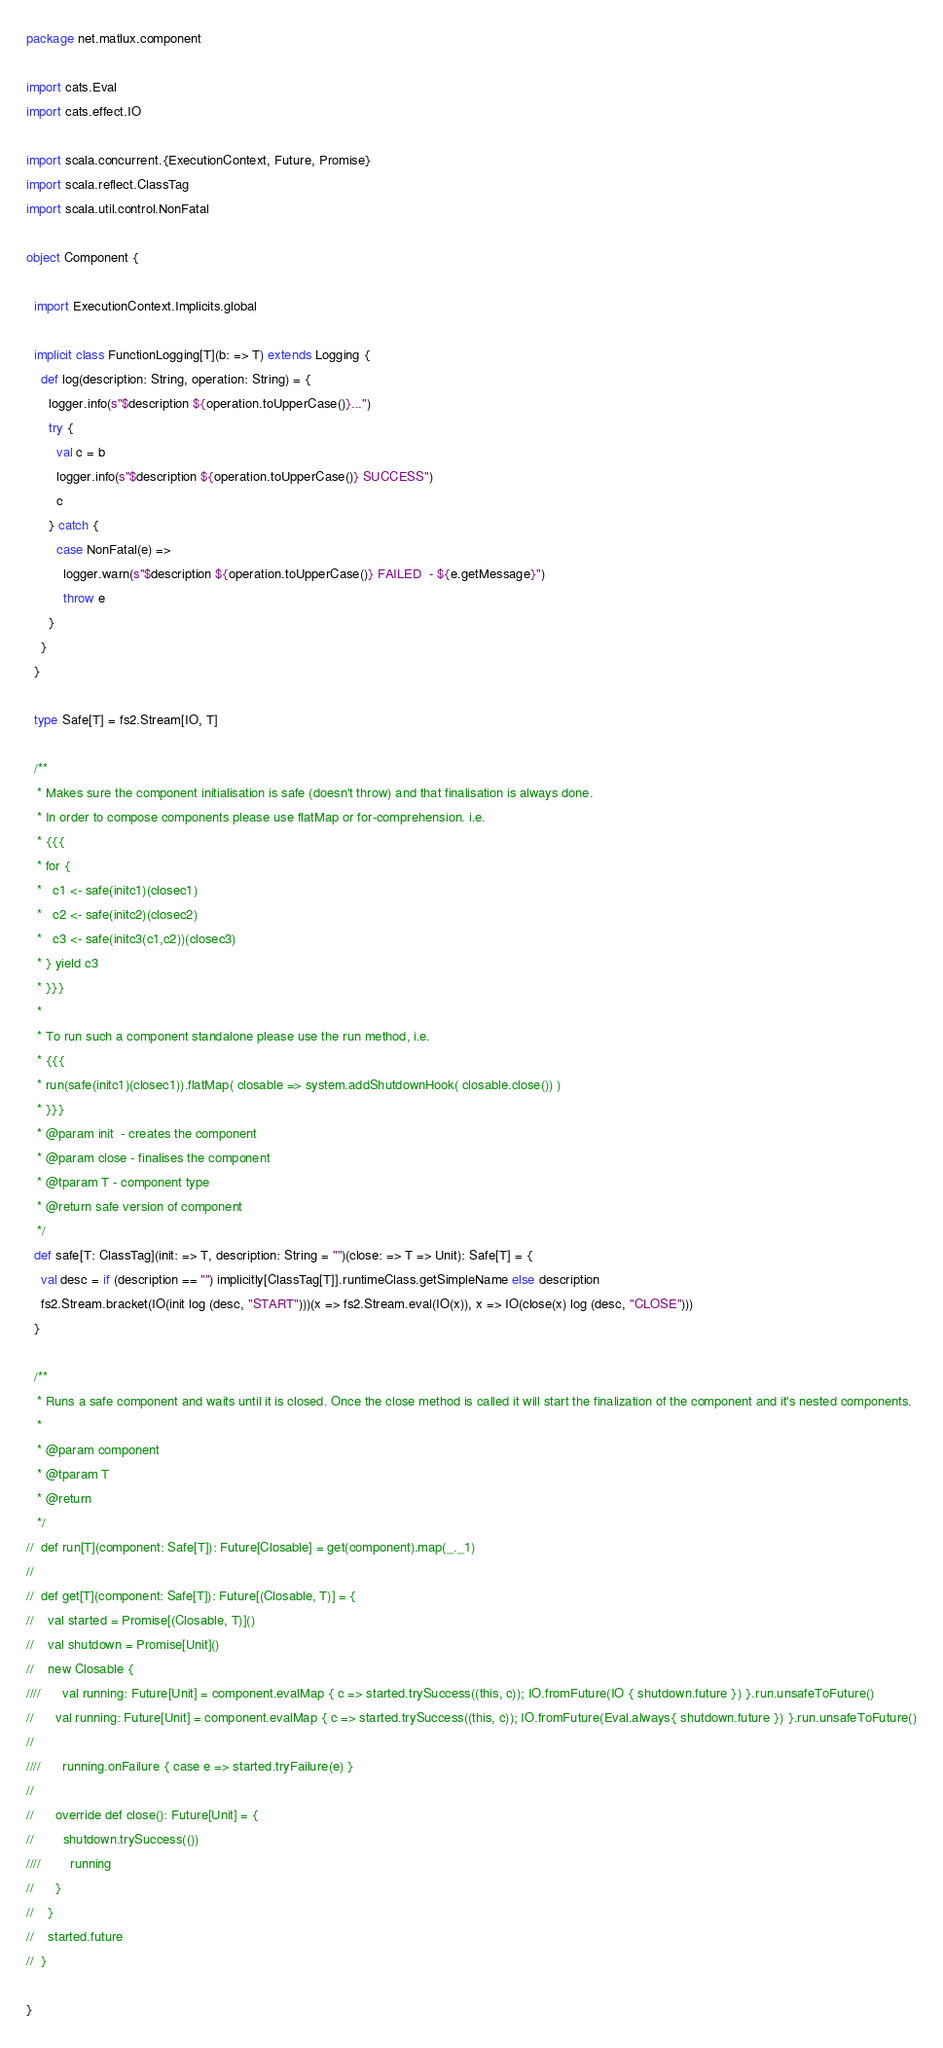Convert code to text. <code><loc_0><loc_0><loc_500><loc_500><_Scala_>package net.matlux.component

import cats.Eval
import cats.effect.IO

import scala.concurrent.{ExecutionContext, Future, Promise}
import scala.reflect.ClassTag
import scala.util.control.NonFatal

object Component {

  import ExecutionContext.Implicits.global

  implicit class FunctionLogging[T](b: => T) extends Logging {
    def log(description: String, operation: String) = {
      logger.info(s"$description ${operation.toUpperCase()}...")
      try {
        val c = b
        logger.info(s"$description ${operation.toUpperCase()} SUCCESS")
        c
      } catch {
        case NonFatal(e) =>
          logger.warn(s"$description ${operation.toUpperCase()} FAILED  - ${e.getMessage}")
          throw e
      }
    }
  }

  type Safe[T] = fs2.Stream[IO, T]

  /**
   * Makes sure the component initialisation is safe (doesn't throw) and that finalisation is always done.
   * In order to compose components please use flatMap or for-comprehension. i.e.
   * {{{
   * for {
   *   c1 <- safe(initc1)(closec1)
   *   c2 <- safe(initc2)(closec2)
   *   c3 <- safe(initc3(c1,c2))(closec3)
   * } yield c3
   * }}}
   *
   * To run such a component standalone please use the run method, i.e.
   * {{{
   * run(safe(initc1)(closec1)).flatMap( closable => system.addShutdownHook( closable.close()) )
   * }}}
   * @param init  - creates the component
   * @param close - finalises the component
   * @tparam T - component type
   * @return safe version of component
   */
  def safe[T: ClassTag](init: => T, description: String = "")(close: => T => Unit): Safe[T] = {
    val desc = if (description == "") implicitly[ClassTag[T]].runtimeClass.getSimpleName else description
    fs2.Stream.bracket(IO(init log (desc, "START")))(x => fs2.Stream.eval(IO(x)), x => IO(close(x) log (desc, "CLOSE")))
  }

  /**
   * Runs a safe component and waits until it is closed. Once the close method is called it will start the finalization of the component and it's nested components.
   *
   * @param component
   * @tparam T
   * @return
   */
//  def run[T](component: Safe[T]): Future[Closable] = get(component).map(_._1)
//
//  def get[T](component: Safe[T]): Future[(Closable, T)] = {
//    val started = Promise[(Closable, T)]()
//    val shutdown = Promise[Unit]()
//    new Closable {
////      val running: Future[Unit] = component.evalMap { c => started.trySuccess((this, c)); IO.fromFuture(IO { shutdown.future }) }.run.unsafeToFuture()
//      val running: Future[Unit] = component.evalMap { c => started.trySuccess((this, c)); IO.fromFuture(Eval.always{ shutdown.future }) }.run.unsafeToFuture()
//
////      running.onFailure { case e => started.tryFailure(e) }
//
//      override def close(): Future[Unit] = {
//        shutdown.trySuccess(())
////        running
//      }
//    }
//    started.future
//  }

}
</code> 